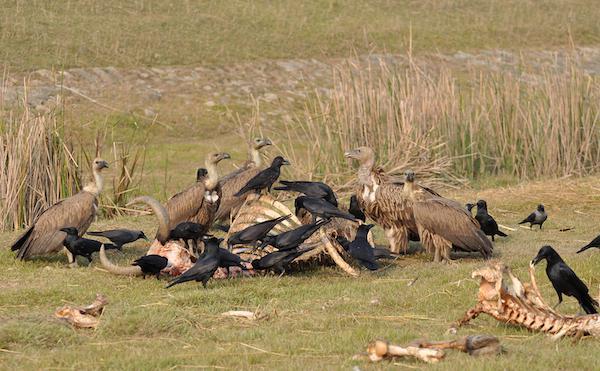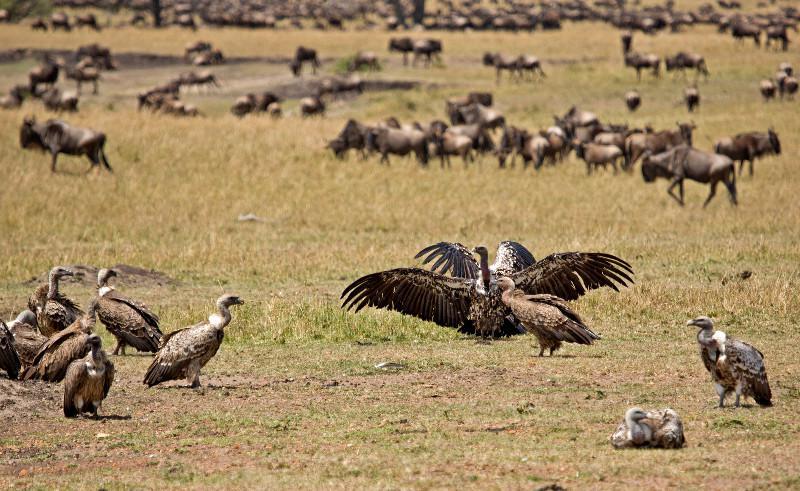The first image is the image on the left, the second image is the image on the right. Evaluate the accuracy of this statement regarding the images: "There are two flying birds in the image on the left.". Is it true? Answer yes or no. No. The first image is the image on the left, the second image is the image on the right. Assess this claim about the two images: "In one image, you can see a line of hooved-type animals in the background behind the vultures.". Correct or not? Answer yes or no. Yes. 